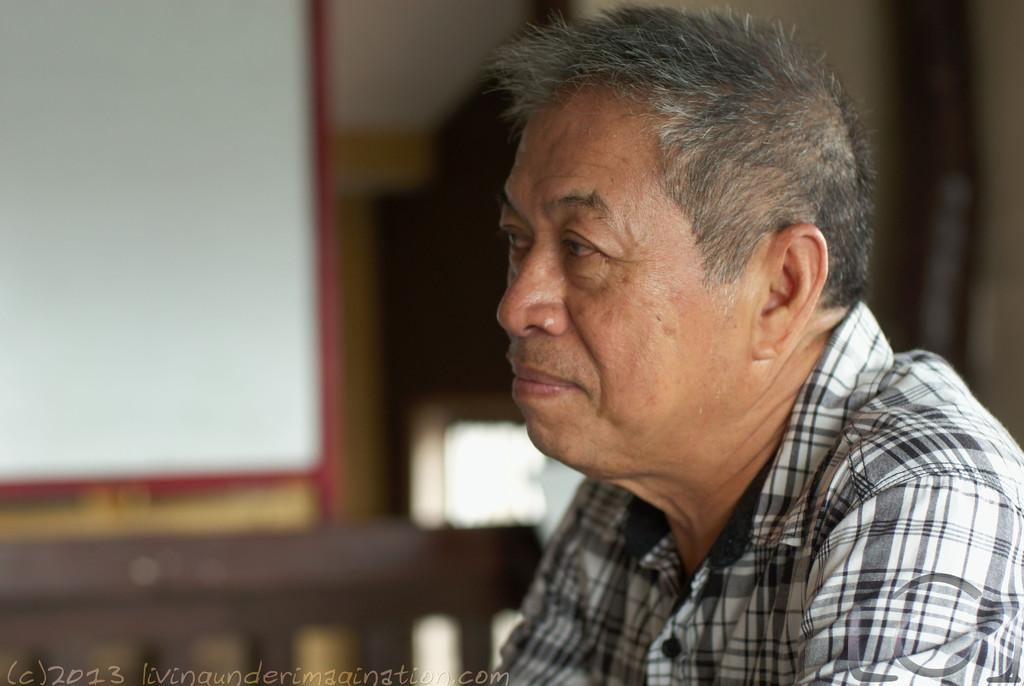Who is present in the image? There is a man in the image. What is the man wearing? The man is wearing a shirt. Can you describe the background of the image? The background of the image is blurry. Is there any additional information or markings in the image? Yes, there is a watermark in the bottom left corner of the image. What is the value of the tin in the image? There is no tin present in the image, so it is not possible to determine its value. 